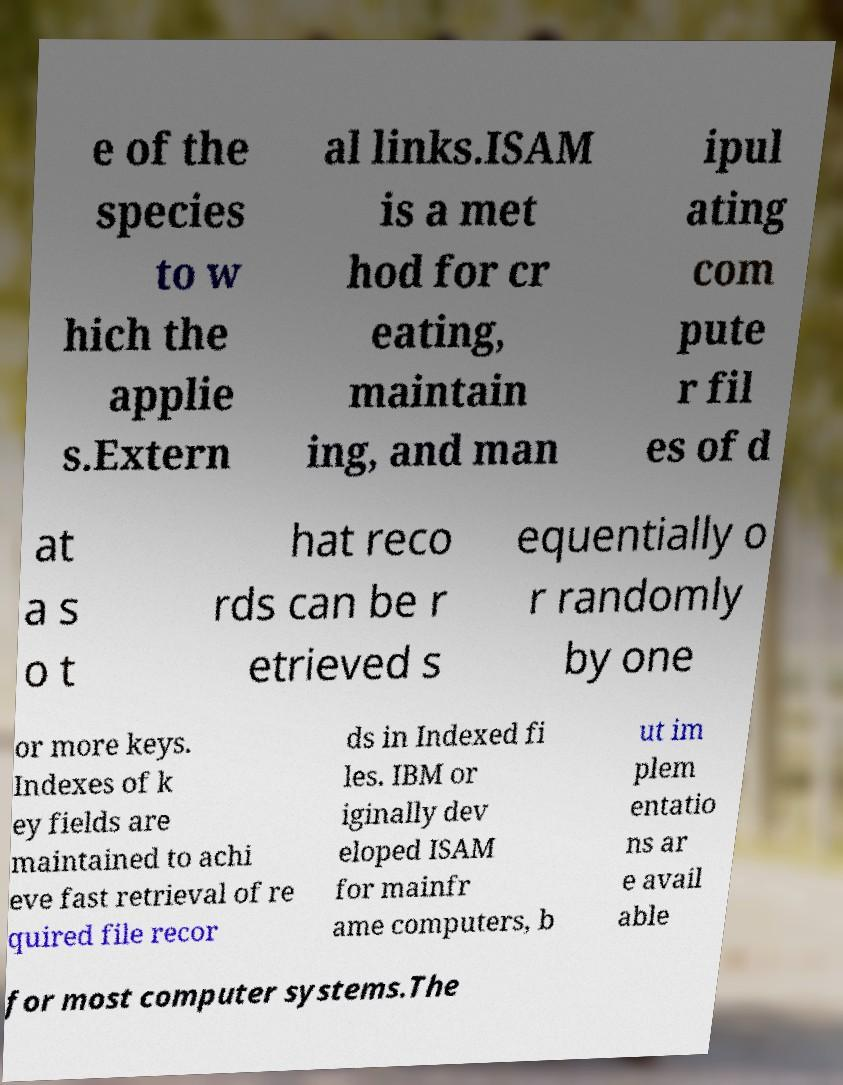Can you read and provide the text displayed in the image?This photo seems to have some interesting text. Can you extract and type it out for me? e of the species to w hich the applie s.Extern al links.ISAM is a met hod for cr eating, maintain ing, and man ipul ating com pute r fil es of d at a s o t hat reco rds can be r etrieved s equentially o r randomly by one or more keys. Indexes of k ey fields are maintained to achi eve fast retrieval of re quired file recor ds in Indexed fi les. IBM or iginally dev eloped ISAM for mainfr ame computers, b ut im plem entatio ns ar e avail able for most computer systems.The 